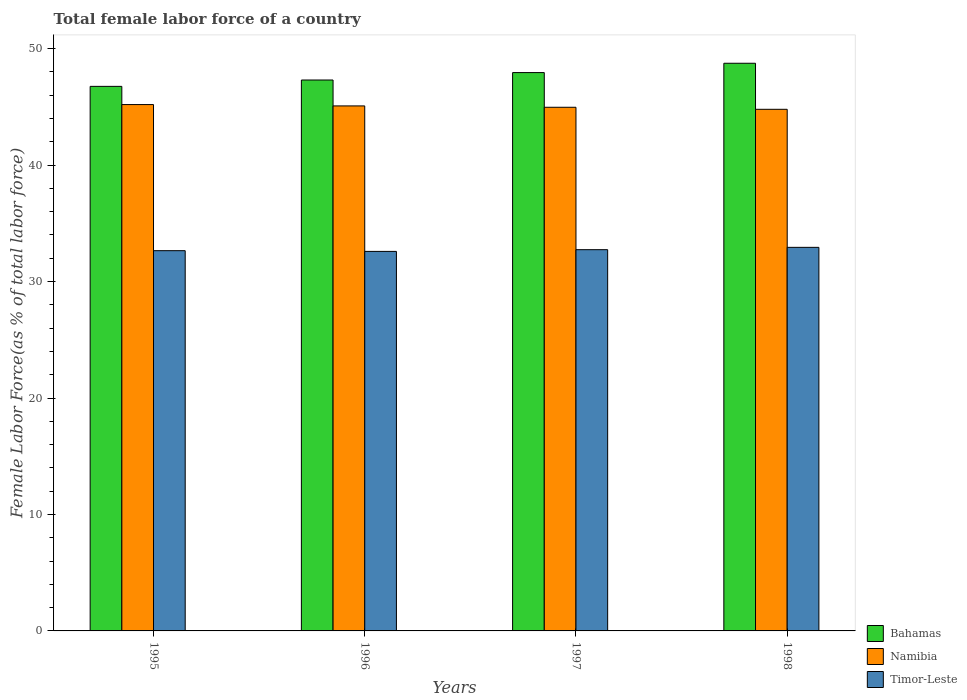How many groups of bars are there?
Your answer should be very brief. 4. How many bars are there on the 4th tick from the left?
Ensure brevity in your answer.  3. How many bars are there on the 4th tick from the right?
Offer a terse response. 3. What is the label of the 3rd group of bars from the left?
Make the answer very short. 1997. In how many cases, is the number of bars for a given year not equal to the number of legend labels?
Provide a succinct answer. 0. What is the percentage of female labor force in Bahamas in 1998?
Offer a very short reply. 48.74. Across all years, what is the maximum percentage of female labor force in Bahamas?
Provide a succinct answer. 48.74. Across all years, what is the minimum percentage of female labor force in Namibia?
Your answer should be very brief. 44.79. In which year was the percentage of female labor force in Namibia minimum?
Your answer should be compact. 1998. What is the total percentage of female labor force in Namibia in the graph?
Give a very brief answer. 180.03. What is the difference between the percentage of female labor force in Timor-Leste in 1995 and that in 1998?
Your answer should be very brief. -0.28. What is the difference between the percentage of female labor force in Bahamas in 1998 and the percentage of female labor force in Namibia in 1995?
Provide a short and direct response. 3.55. What is the average percentage of female labor force in Namibia per year?
Your response must be concise. 45.01. In the year 1997, what is the difference between the percentage of female labor force in Timor-Leste and percentage of female labor force in Bahamas?
Your answer should be very brief. -15.21. In how many years, is the percentage of female labor force in Bahamas greater than 18 %?
Your answer should be very brief. 4. What is the ratio of the percentage of female labor force in Namibia in 1996 to that in 1998?
Your response must be concise. 1.01. Is the difference between the percentage of female labor force in Timor-Leste in 1995 and 1996 greater than the difference between the percentage of female labor force in Bahamas in 1995 and 1996?
Keep it short and to the point. Yes. What is the difference between the highest and the second highest percentage of female labor force in Timor-Leste?
Offer a terse response. 0.2. What is the difference between the highest and the lowest percentage of female labor force in Bahamas?
Your answer should be compact. 1.98. What does the 1st bar from the left in 1995 represents?
Keep it short and to the point. Bahamas. What does the 3rd bar from the right in 1998 represents?
Give a very brief answer. Bahamas. Are all the bars in the graph horizontal?
Provide a short and direct response. No. How many years are there in the graph?
Provide a short and direct response. 4. What is the difference between two consecutive major ticks on the Y-axis?
Ensure brevity in your answer.  10. Does the graph contain any zero values?
Ensure brevity in your answer.  No. Where does the legend appear in the graph?
Provide a short and direct response. Bottom right. How many legend labels are there?
Provide a short and direct response. 3. How are the legend labels stacked?
Keep it short and to the point. Vertical. What is the title of the graph?
Make the answer very short. Total female labor force of a country. What is the label or title of the X-axis?
Keep it short and to the point. Years. What is the label or title of the Y-axis?
Keep it short and to the point. Female Labor Force(as % of total labor force). What is the Female Labor Force(as % of total labor force) of Bahamas in 1995?
Offer a terse response. 46.76. What is the Female Labor Force(as % of total labor force) of Namibia in 1995?
Your response must be concise. 45.2. What is the Female Labor Force(as % of total labor force) in Timor-Leste in 1995?
Give a very brief answer. 32.65. What is the Female Labor Force(as % of total labor force) of Bahamas in 1996?
Your answer should be very brief. 47.3. What is the Female Labor Force(as % of total labor force) in Namibia in 1996?
Your answer should be compact. 45.08. What is the Female Labor Force(as % of total labor force) of Timor-Leste in 1996?
Provide a succinct answer. 32.59. What is the Female Labor Force(as % of total labor force) of Bahamas in 1997?
Give a very brief answer. 47.94. What is the Female Labor Force(as % of total labor force) in Namibia in 1997?
Offer a very short reply. 44.96. What is the Female Labor Force(as % of total labor force) in Timor-Leste in 1997?
Make the answer very short. 32.74. What is the Female Labor Force(as % of total labor force) in Bahamas in 1998?
Your answer should be very brief. 48.74. What is the Female Labor Force(as % of total labor force) in Namibia in 1998?
Give a very brief answer. 44.79. What is the Female Labor Force(as % of total labor force) of Timor-Leste in 1998?
Provide a short and direct response. 32.94. Across all years, what is the maximum Female Labor Force(as % of total labor force) in Bahamas?
Give a very brief answer. 48.74. Across all years, what is the maximum Female Labor Force(as % of total labor force) in Namibia?
Offer a very short reply. 45.2. Across all years, what is the maximum Female Labor Force(as % of total labor force) of Timor-Leste?
Offer a very short reply. 32.94. Across all years, what is the minimum Female Labor Force(as % of total labor force) of Bahamas?
Your answer should be very brief. 46.76. Across all years, what is the minimum Female Labor Force(as % of total labor force) in Namibia?
Provide a succinct answer. 44.79. Across all years, what is the minimum Female Labor Force(as % of total labor force) of Timor-Leste?
Your answer should be compact. 32.59. What is the total Female Labor Force(as % of total labor force) in Bahamas in the graph?
Ensure brevity in your answer.  190.75. What is the total Female Labor Force(as % of total labor force) of Namibia in the graph?
Give a very brief answer. 180.03. What is the total Female Labor Force(as % of total labor force) of Timor-Leste in the graph?
Your response must be concise. 130.91. What is the difference between the Female Labor Force(as % of total labor force) of Bahamas in 1995 and that in 1996?
Your answer should be compact. -0.55. What is the difference between the Female Labor Force(as % of total labor force) of Namibia in 1995 and that in 1996?
Your answer should be very brief. 0.12. What is the difference between the Female Labor Force(as % of total labor force) of Timor-Leste in 1995 and that in 1996?
Your response must be concise. 0.06. What is the difference between the Female Labor Force(as % of total labor force) of Bahamas in 1995 and that in 1997?
Your answer should be very brief. -1.18. What is the difference between the Female Labor Force(as % of total labor force) in Namibia in 1995 and that in 1997?
Give a very brief answer. 0.23. What is the difference between the Female Labor Force(as % of total labor force) of Timor-Leste in 1995 and that in 1997?
Give a very brief answer. -0.09. What is the difference between the Female Labor Force(as % of total labor force) of Bahamas in 1995 and that in 1998?
Keep it short and to the point. -1.98. What is the difference between the Female Labor Force(as % of total labor force) of Namibia in 1995 and that in 1998?
Keep it short and to the point. 0.41. What is the difference between the Female Labor Force(as % of total labor force) of Timor-Leste in 1995 and that in 1998?
Offer a very short reply. -0.28. What is the difference between the Female Labor Force(as % of total labor force) of Bahamas in 1996 and that in 1997?
Provide a short and direct response. -0.64. What is the difference between the Female Labor Force(as % of total labor force) in Namibia in 1996 and that in 1997?
Make the answer very short. 0.12. What is the difference between the Female Labor Force(as % of total labor force) of Timor-Leste in 1996 and that in 1997?
Provide a short and direct response. -0.15. What is the difference between the Female Labor Force(as % of total labor force) in Bahamas in 1996 and that in 1998?
Your response must be concise. -1.44. What is the difference between the Female Labor Force(as % of total labor force) of Namibia in 1996 and that in 1998?
Ensure brevity in your answer.  0.29. What is the difference between the Female Labor Force(as % of total labor force) of Timor-Leste in 1996 and that in 1998?
Your answer should be compact. -0.35. What is the difference between the Female Labor Force(as % of total labor force) in Bahamas in 1997 and that in 1998?
Offer a very short reply. -0.8. What is the difference between the Female Labor Force(as % of total labor force) in Namibia in 1997 and that in 1998?
Keep it short and to the point. 0.17. What is the difference between the Female Labor Force(as % of total labor force) in Timor-Leste in 1997 and that in 1998?
Your answer should be compact. -0.2. What is the difference between the Female Labor Force(as % of total labor force) of Bahamas in 1995 and the Female Labor Force(as % of total labor force) of Namibia in 1996?
Keep it short and to the point. 1.68. What is the difference between the Female Labor Force(as % of total labor force) in Bahamas in 1995 and the Female Labor Force(as % of total labor force) in Timor-Leste in 1996?
Offer a terse response. 14.17. What is the difference between the Female Labor Force(as % of total labor force) in Namibia in 1995 and the Female Labor Force(as % of total labor force) in Timor-Leste in 1996?
Make the answer very short. 12.61. What is the difference between the Female Labor Force(as % of total labor force) of Bahamas in 1995 and the Female Labor Force(as % of total labor force) of Namibia in 1997?
Keep it short and to the point. 1.8. What is the difference between the Female Labor Force(as % of total labor force) of Bahamas in 1995 and the Female Labor Force(as % of total labor force) of Timor-Leste in 1997?
Ensure brevity in your answer.  14.02. What is the difference between the Female Labor Force(as % of total labor force) of Namibia in 1995 and the Female Labor Force(as % of total labor force) of Timor-Leste in 1997?
Provide a succinct answer. 12.46. What is the difference between the Female Labor Force(as % of total labor force) of Bahamas in 1995 and the Female Labor Force(as % of total labor force) of Namibia in 1998?
Provide a succinct answer. 1.97. What is the difference between the Female Labor Force(as % of total labor force) in Bahamas in 1995 and the Female Labor Force(as % of total labor force) in Timor-Leste in 1998?
Your response must be concise. 13.82. What is the difference between the Female Labor Force(as % of total labor force) in Namibia in 1995 and the Female Labor Force(as % of total labor force) in Timor-Leste in 1998?
Your answer should be compact. 12.26. What is the difference between the Female Labor Force(as % of total labor force) in Bahamas in 1996 and the Female Labor Force(as % of total labor force) in Namibia in 1997?
Give a very brief answer. 2.34. What is the difference between the Female Labor Force(as % of total labor force) of Bahamas in 1996 and the Female Labor Force(as % of total labor force) of Timor-Leste in 1997?
Your answer should be very brief. 14.57. What is the difference between the Female Labor Force(as % of total labor force) of Namibia in 1996 and the Female Labor Force(as % of total labor force) of Timor-Leste in 1997?
Offer a terse response. 12.35. What is the difference between the Female Labor Force(as % of total labor force) in Bahamas in 1996 and the Female Labor Force(as % of total labor force) in Namibia in 1998?
Give a very brief answer. 2.51. What is the difference between the Female Labor Force(as % of total labor force) of Bahamas in 1996 and the Female Labor Force(as % of total labor force) of Timor-Leste in 1998?
Your response must be concise. 14.37. What is the difference between the Female Labor Force(as % of total labor force) in Namibia in 1996 and the Female Labor Force(as % of total labor force) in Timor-Leste in 1998?
Give a very brief answer. 12.15. What is the difference between the Female Labor Force(as % of total labor force) in Bahamas in 1997 and the Female Labor Force(as % of total labor force) in Namibia in 1998?
Provide a succinct answer. 3.15. What is the difference between the Female Labor Force(as % of total labor force) of Bahamas in 1997 and the Female Labor Force(as % of total labor force) of Timor-Leste in 1998?
Provide a succinct answer. 15.01. What is the difference between the Female Labor Force(as % of total labor force) in Namibia in 1997 and the Female Labor Force(as % of total labor force) in Timor-Leste in 1998?
Ensure brevity in your answer.  12.03. What is the average Female Labor Force(as % of total labor force) of Bahamas per year?
Give a very brief answer. 47.69. What is the average Female Labor Force(as % of total labor force) in Namibia per year?
Ensure brevity in your answer.  45.01. What is the average Female Labor Force(as % of total labor force) of Timor-Leste per year?
Your response must be concise. 32.73. In the year 1995, what is the difference between the Female Labor Force(as % of total labor force) of Bahamas and Female Labor Force(as % of total labor force) of Namibia?
Your answer should be compact. 1.56. In the year 1995, what is the difference between the Female Labor Force(as % of total labor force) in Bahamas and Female Labor Force(as % of total labor force) in Timor-Leste?
Ensure brevity in your answer.  14.11. In the year 1995, what is the difference between the Female Labor Force(as % of total labor force) in Namibia and Female Labor Force(as % of total labor force) in Timor-Leste?
Ensure brevity in your answer.  12.55. In the year 1996, what is the difference between the Female Labor Force(as % of total labor force) in Bahamas and Female Labor Force(as % of total labor force) in Namibia?
Provide a succinct answer. 2.22. In the year 1996, what is the difference between the Female Labor Force(as % of total labor force) in Bahamas and Female Labor Force(as % of total labor force) in Timor-Leste?
Your answer should be compact. 14.72. In the year 1996, what is the difference between the Female Labor Force(as % of total labor force) in Namibia and Female Labor Force(as % of total labor force) in Timor-Leste?
Your response must be concise. 12.49. In the year 1997, what is the difference between the Female Labor Force(as % of total labor force) in Bahamas and Female Labor Force(as % of total labor force) in Namibia?
Your answer should be very brief. 2.98. In the year 1997, what is the difference between the Female Labor Force(as % of total labor force) in Bahamas and Female Labor Force(as % of total labor force) in Timor-Leste?
Provide a succinct answer. 15.21. In the year 1997, what is the difference between the Female Labor Force(as % of total labor force) of Namibia and Female Labor Force(as % of total labor force) of Timor-Leste?
Offer a terse response. 12.23. In the year 1998, what is the difference between the Female Labor Force(as % of total labor force) in Bahamas and Female Labor Force(as % of total labor force) in Namibia?
Ensure brevity in your answer.  3.95. In the year 1998, what is the difference between the Female Labor Force(as % of total labor force) in Bahamas and Female Labor Force(as % of total labor force) in Timor-Leste?
Provide a short and direct response. 15.81. In the year 1998, what is the difference between the Female Labor Force(as % of total labor force) of Namibia and Female Labor Force(as % of total labor force) of Timor-Leste?
Ensure brevity in your answer.  11.85. What is the ratio of the Female Labor Force(as % of total labor force) of Bahamas in 1995 to that in 1996?
Your response must be concise. 0.99. What is the ratio of the Female Labor Force(as % of total labor force) of Namibia in 1995 to that in 1996?
Provide a succinct answer. 1. What is the ratio of the Female Labor Force(as % of total labor force) of Bahamas in 1995 to that in 1997?
Make the answer very short. 0.98. What is the ratio of the Female Labor Force(as % of total labor force) in Namibia in 1995 to that in 1997?
Your answer should be compact. 1.01. What is the ratio of the Female Labor Force(as % of total labor force) of Timor-Leste in 1995 to that in 1997?
Keep it short and to the point. 1. What is the ratio of the Female Labor Force(as % of total labor force) of Bahamas in 1995 to that in 1998?
Your answer should be very brief. 0.96. What is the ratio of the Female Labor Force(as % of total labor force) in Namibia in 1995 to that in 1998?
Make the answer very short. 1.01. What is the ratio of the Female Labor Force(as % of total labor force) in Timor-Leste in 1995 to that in 1998?
Keep it short and to the point. 0.99. What is the ratio of the Female Labor Force(as % of total labor force) of Bahamas in 1996 to that in 1997?
Provide a short and direct response. 0.99. What is the ratio of the Female Labor Force(as % of total labor force) in Bahamas in 1996 to that in 1998?
Make the answer very short. 0.97. What is the ratio of the Female Labor Force(as % of total labor force) in Timor-Leste in 1996 to that in 1998?
Offer a terse response. 0.99. What is the ratio of the Female Labor Force(as % of total labor force) of Bahamas in 1997 to that in 1998?
Keep it short and to the point. 0.98. What is the difference between the highest and the second highest Female Labor Force(as % of total labor force) in Bahamas?
Offer a terse response. 0.8. What is the difference between the highest and the second highest Female Labor Force(as % of total labor force) in Namibia?
Give a very brief answer. 0.12. What is the difference between the highest and the second highest Female Labor Force(as % of total labor force) in Timor-Leste?
Give a very brief answer. 0.2. What is the difference between the highest and the lowest Female Labor Force(as % of total labor force) in Bahamas?
Your answer should be compact. 1.98. What is the difference between the highest and the lowest Female Labor Force(as % of total labor force) of Namibia?
Ensure brevity in your answer.  0.41. What is the difference between the highest and the lowest Female Labor Force(as % of total labor force) of Timor-Leste?
Provide a succinct answer. 0.35. 